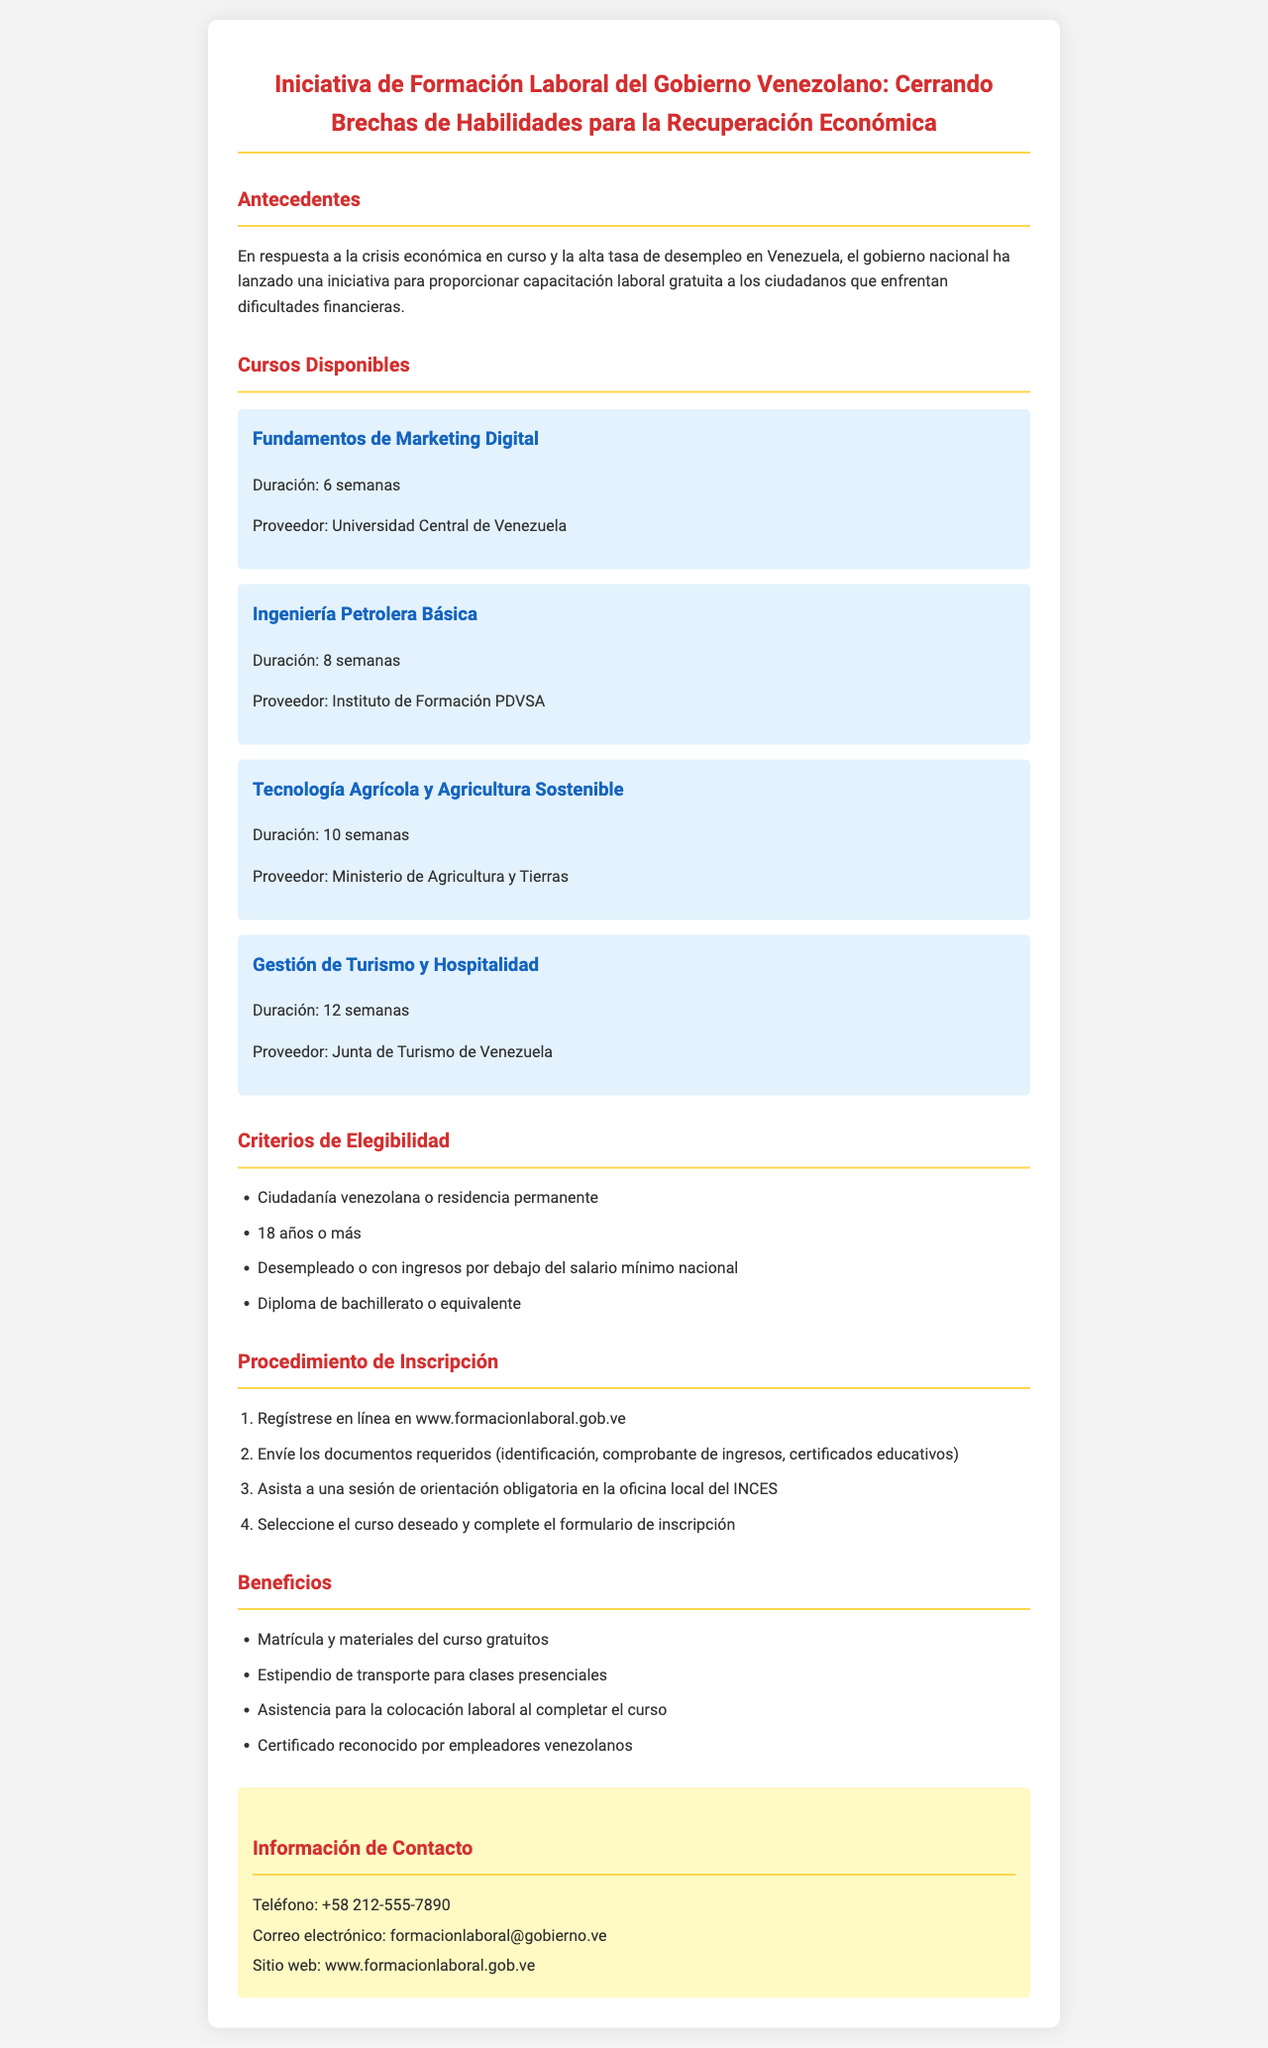¿Cuál es el propósito de la iniciativa? El propósito declarado en el documento es proporcionar capacitación laboral gratuita a los ciudadanos que enfrentan dificultades financieras debido a la crisis económica y la alta tasa de desempleo.
Answer: Proporcionar capacitación laboral gratuita ¿Cuántas semanas dura el curso de Fundamentos de Marketing Digital? La duración del curso de Fundamentos de Marketing Digital se menciona en el documento como 6 semanas.
Answer: 6 semanas ¿Quién proporciona el curso de Ingeniería Petrolera Básica? El proveedor del curso de Ingeniería Petrolera Básica se especifica en el documento, que es el Instituto de Formación PDVSA.
Answer: Instituto de Formación PDVSA ¿Qué debe enviar un solicitante durante el procedimiento de inscripción? Se menciona en el procedimiento de inscripción que el solicitante debe enviar documentos requeridos como identificación, comprobante de ingresos, y certificados educativos.
Answer: Identificación, comprobante de ingresos, certificados educativos ¿Cuántos criterios de elegibilidad se mencionan? El documento enumera cuatro criterios de elegibilidad que los solicitantes deben cumplir para inscribirse en los cursos.
Answer: 4 criterios ¿Qué tipo de asistencia se proporciona al finalizar un curso? Se indica que los beneficiarios recibirán asistencia para la colocación laboral al completar el curso.
Answer: Asistencia para la colocación laboral ¿Cuál es la duración del curso de Gestión de Turismo y Hospitalidad? El documento menciona que la duración del curso de Gestión de Turismo y Hospitalidad es de 12 semanas.
Answer: 12 semanas ¿Dónde se debe asistir para una sesión de orientación? El documento aclara que los solicitantes deben asistir a una sesión de orientación obligatoria en la oficina local del INCES.
Answer: Oficina local del INCES ¿Cuál es el contacto telefónico proporcionado para más información? El número de contacto telefónico disponible para solicitar más información se encuentra en el documento y es +58 212-555-7890.
Answer: +58 212-555-7890 